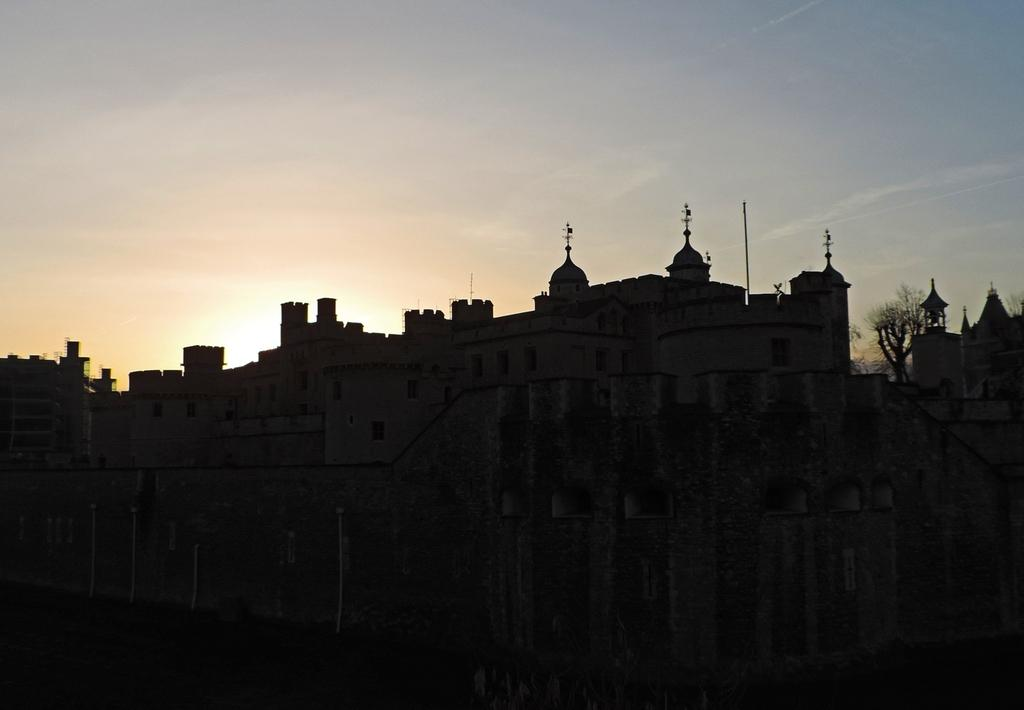What is the overall lighting condition in the image? The image is dark. What type of structures can be seen in the image? There are buildings in the image. What can be seen in the background of the image? The sky and trees are visible in the background of the image. How does the tree in the image maintain its balance? The image does not show any trees maintaining their balance, as it is focused on the buildings and the overall dark lighting condition. 